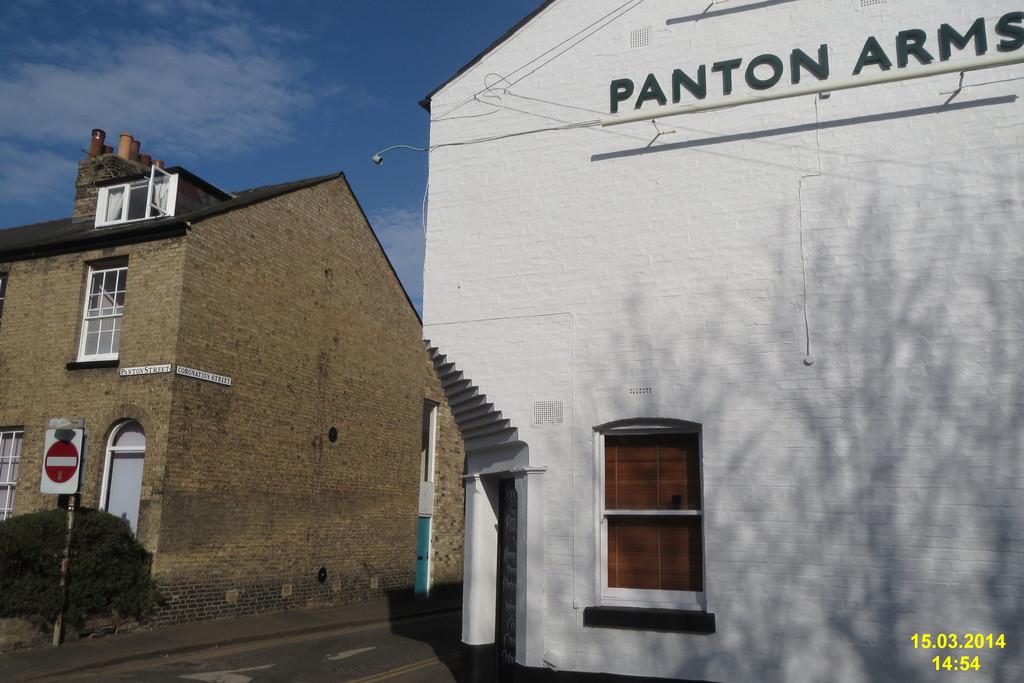What is the name on the white building?
Ensure brevity in your answer.  Panton arms. When was this taken?
Offer a very short reply. 15.03.2014. 